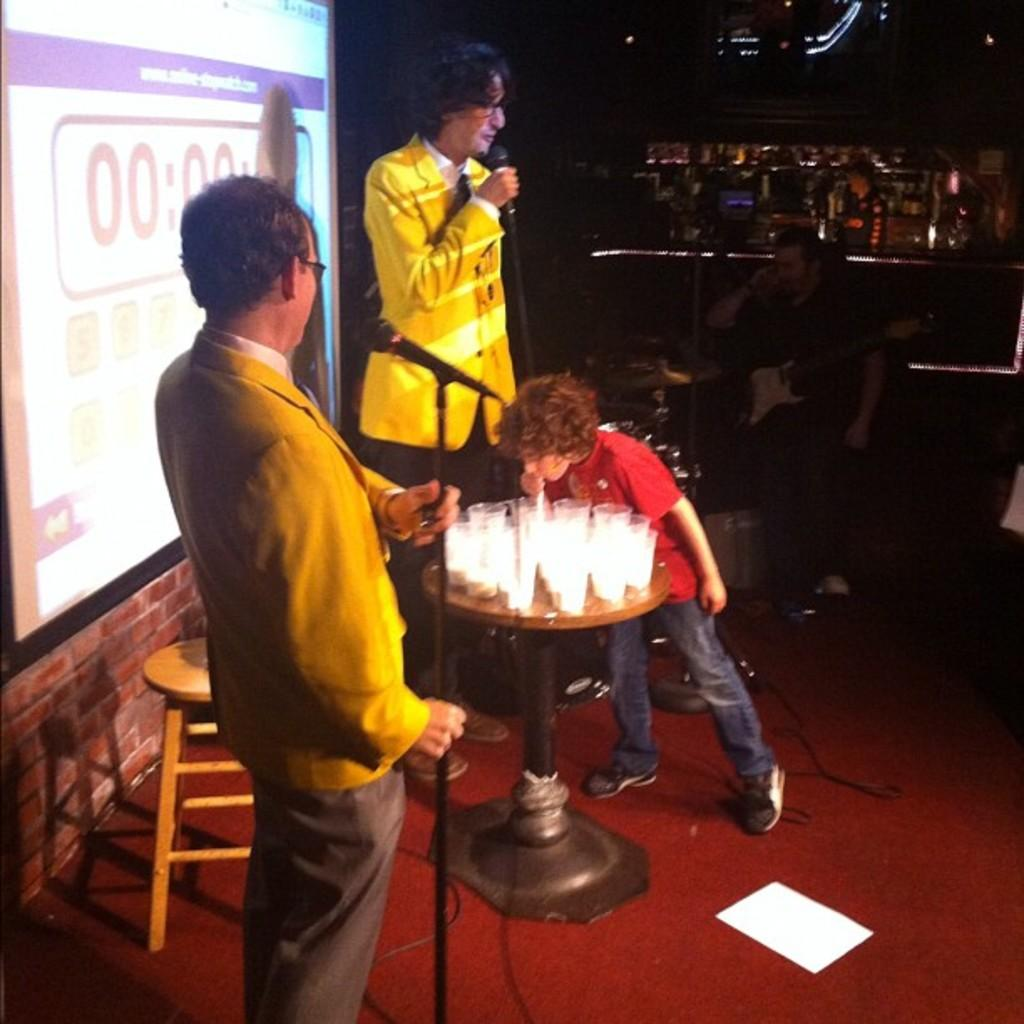How many people are in the image? There are four persons in the image. What is one person doing in the image? One person is holding a microphone. What objects can be seen on the table in the image? There are glasses and a paper on the table in the image. What furniture is present in the image? There is a table and chairs in the image. What type of equipment is visible in the image? There is a screen and microphones in the image. What lighting is present in the image? There are lights in the image. What is the color of the background in the image? The background of the image is dark. Can you see any insects crawling on the table in the image? There are no insects visible in the image. What type of root is growing on the table in the image? There are no roots present in the image. 